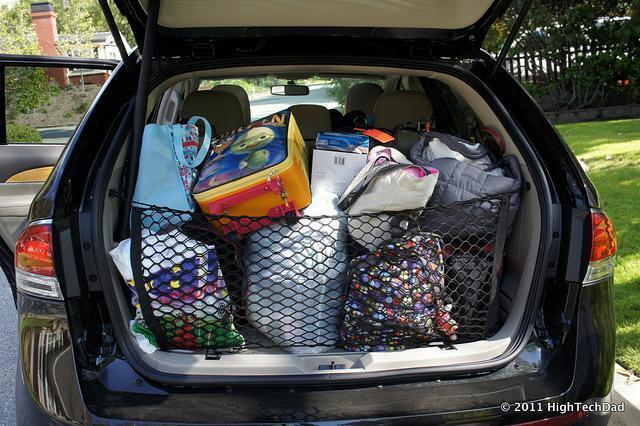How many handbags are there?
Give a very brief answer. 3. How many men have a bat?
Give a very brief answer. 0. 